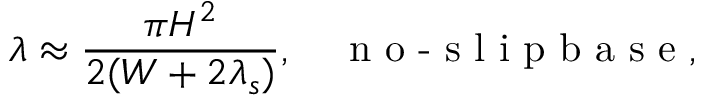<formula> <loc_0><loc_0><loc_500><loc_500>\lambda \approx \frac { \pi H ^ { 2 } } { 2 ( W + 2 \lambda _ { s } ) } , n o - s l i p b a s e ,</formula> 